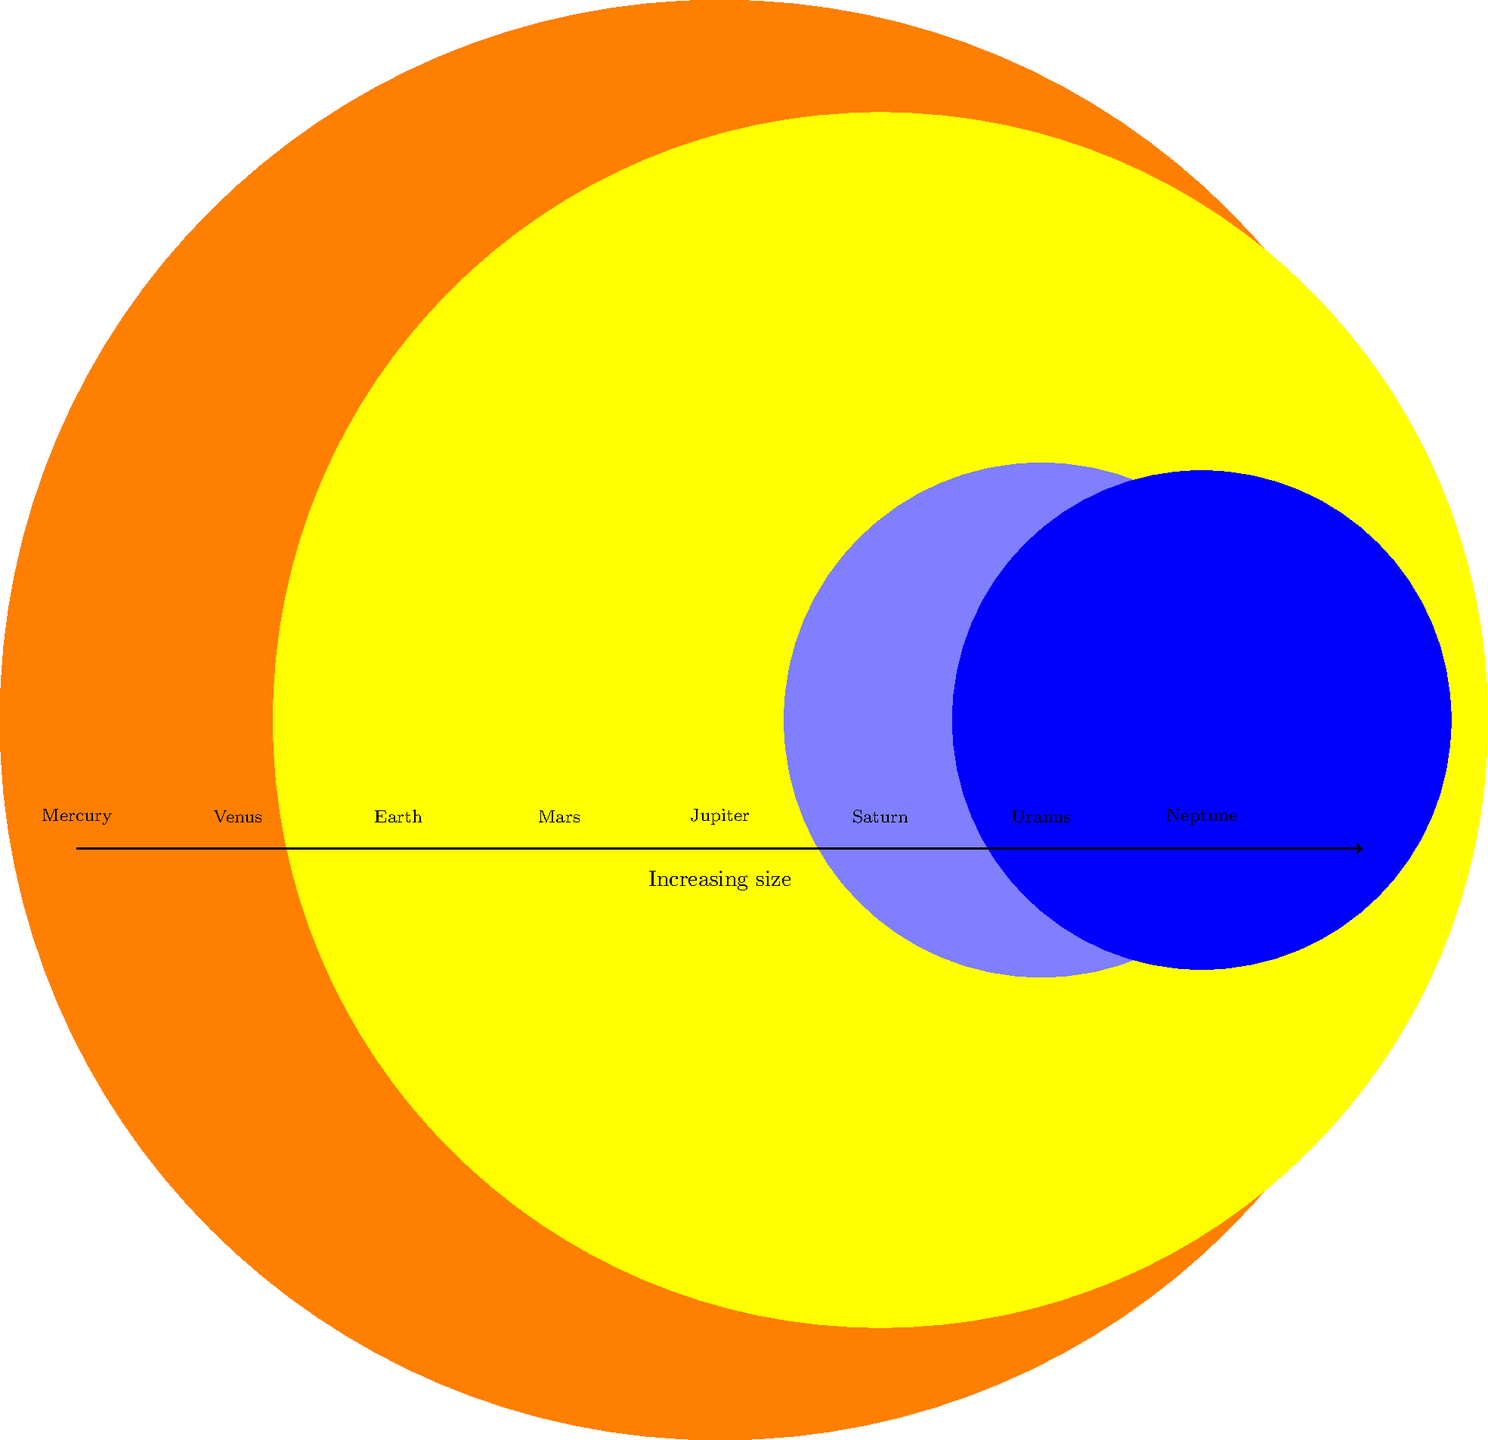In the image above, the planets of our solar system are represented by scaled circles. Which planet is represented by the largest circle, reminding you of the massive battleships that once sailed the seas during World War II? Let's approach this step-by-step:

1. First, we need to identify all the planets shown in the image. From left to right, we see Mercury, Venus, Earth, Mars, Jupiter, Saturn, Uranus, and Neptune.

2. Now, we need to compare the sizes of the circles representing each planet. The largest circle will represent the largest planet in our solar system.

3. Looking at the image, we can clearly see that the fifth circle from the left is significantly larger than all the others.

4. This largest circle is labeled "Jupiter".

5. Jupiter is indeed the largest planet in our solar system, with a radius about 11 times that of Earth.

6. The analogy to World War II battleships is apt, as Jupiter's enormous size in comparison to the other planets is similar to how the massive battleships of WWII dwarfed other naval vessels of the time.
Answer: Jupiter 